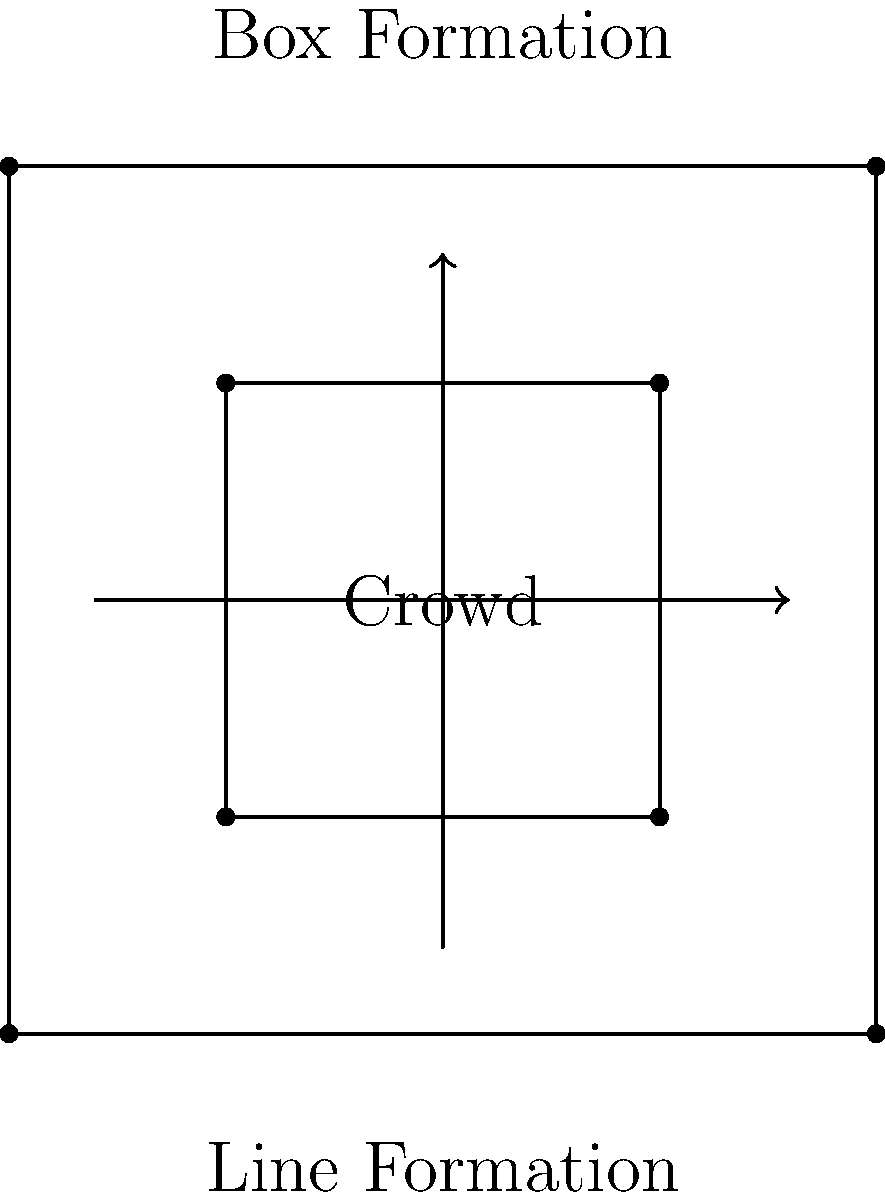Based on the diagram, which crowd control formation would be most effective for channeling a crowd in a specific direction while maintaining a strong perimeter? To answer this question, let's analyze the two formations shown in the diagram:

1. Line Formation (bottom):
   - Pros: Good for pushing crowds in a single direction
   - Cons: Weak perimeter control, easily breached

2. Box Formation (top):
   - Pros: Strong perimeter control, flexible movement
   - Cons: Less effective for directional crowd movement

Step-by-step analysis:
1. The question asks for a formation that can channel crowds in a specific direction while maintaining a strong perimeter.
2. The Line Formation is effective for pushing crowds in one direction but lacks strong perimeter control.
3. The Box Formation provides excellent perimeter control but is less effective for directional movement.
4. However, the Box Formation can be adapted to channel crowds by creating a "funnel" shape or opening one side to guide the crowd.
5. This adaptation of the Box Formation allows for both directional control and strong perimeter maintenance.

Therefore, the Box Formation, when properly adapted, would be the most effective for the given requirements.
Answer: Box Formation (adapted) 